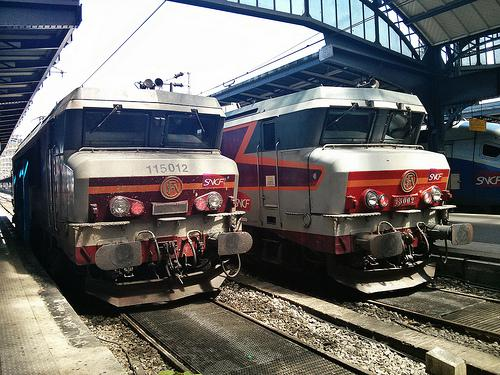Question: who rides in the train?
Choices:
A. People.
B. Dogs.
C. Cats.
D. Clowns.
Answer with the letter. Answer: A Question: where is this taken?
Choices:
A. A park.
B. Train station.
C. A bathroom.
D. An office.
Answer with the letter. Answer: B Question: what are the trains on?
Choices:
A. Skis.
B. Skates.
C. Tracks.
D. Tires.
Answer with the letter. Answer: C 